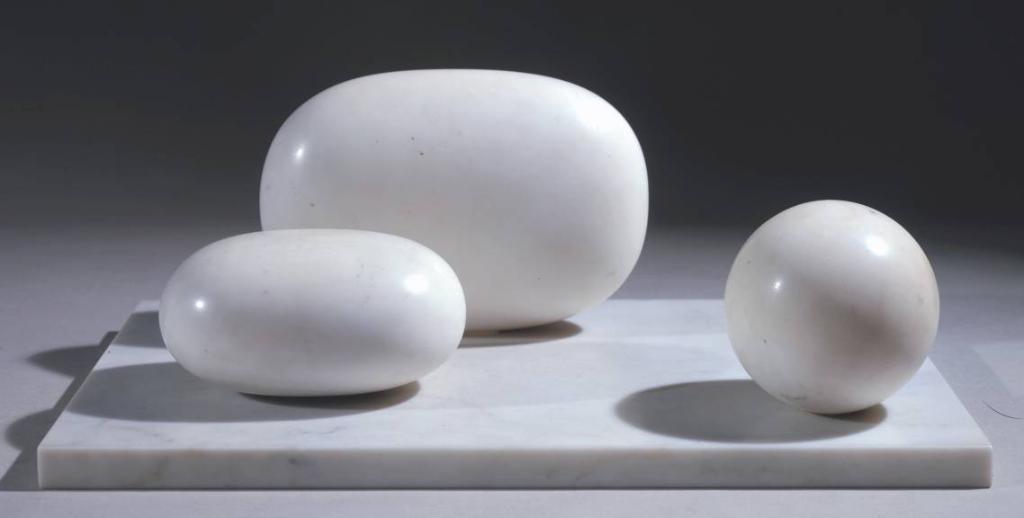How would you summarize this image in a sentence or two? In this image, we can see different shapes of stones. 